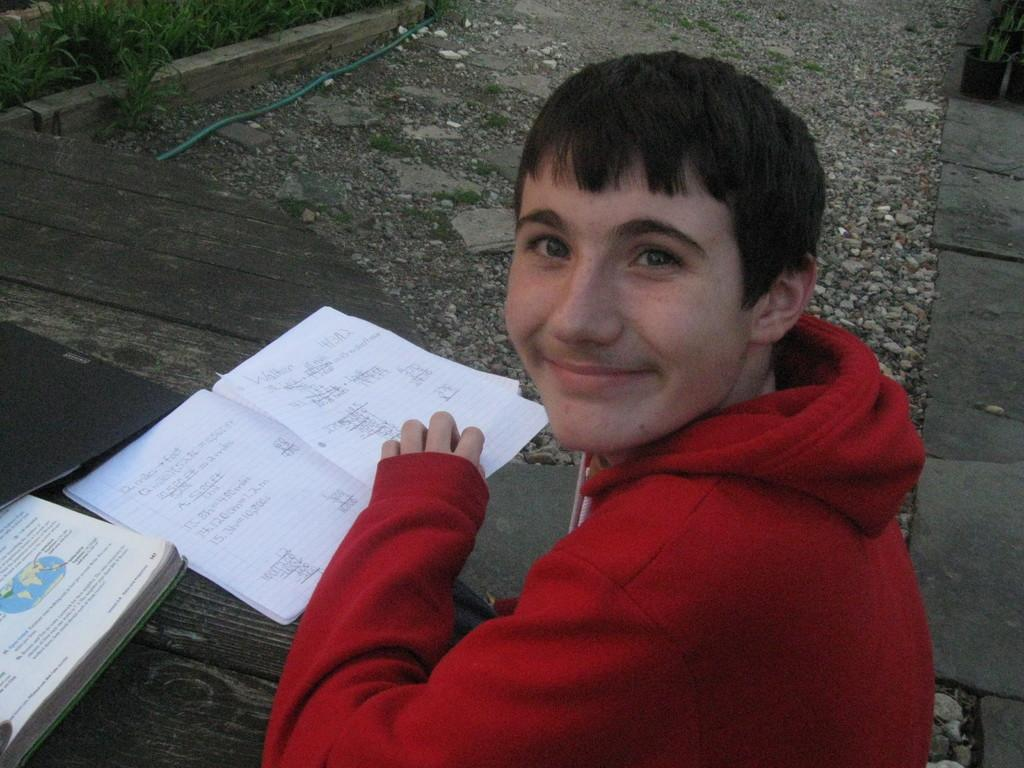Who or what is the main subject in the image? There is a person in the image. What is the person wearing? The person is wearing a red jacket. What objects are in front of the person? There are books in front of the person. What type of disgust can be seen on the person's face in the image? There is no indication of disgust on the person's face in the image. 